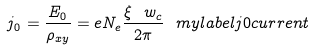<formula> <loc_0><loc_0><loc_500><loc_500>j _ { 0 } = \frac { E _ { 0 } } { \rho _ { x y } } = e N _ { e } \frac { \xi \ w _ { c } } { 2 \pi } \ m y l a b e l { j 0 c u r r e n t }</formula> 